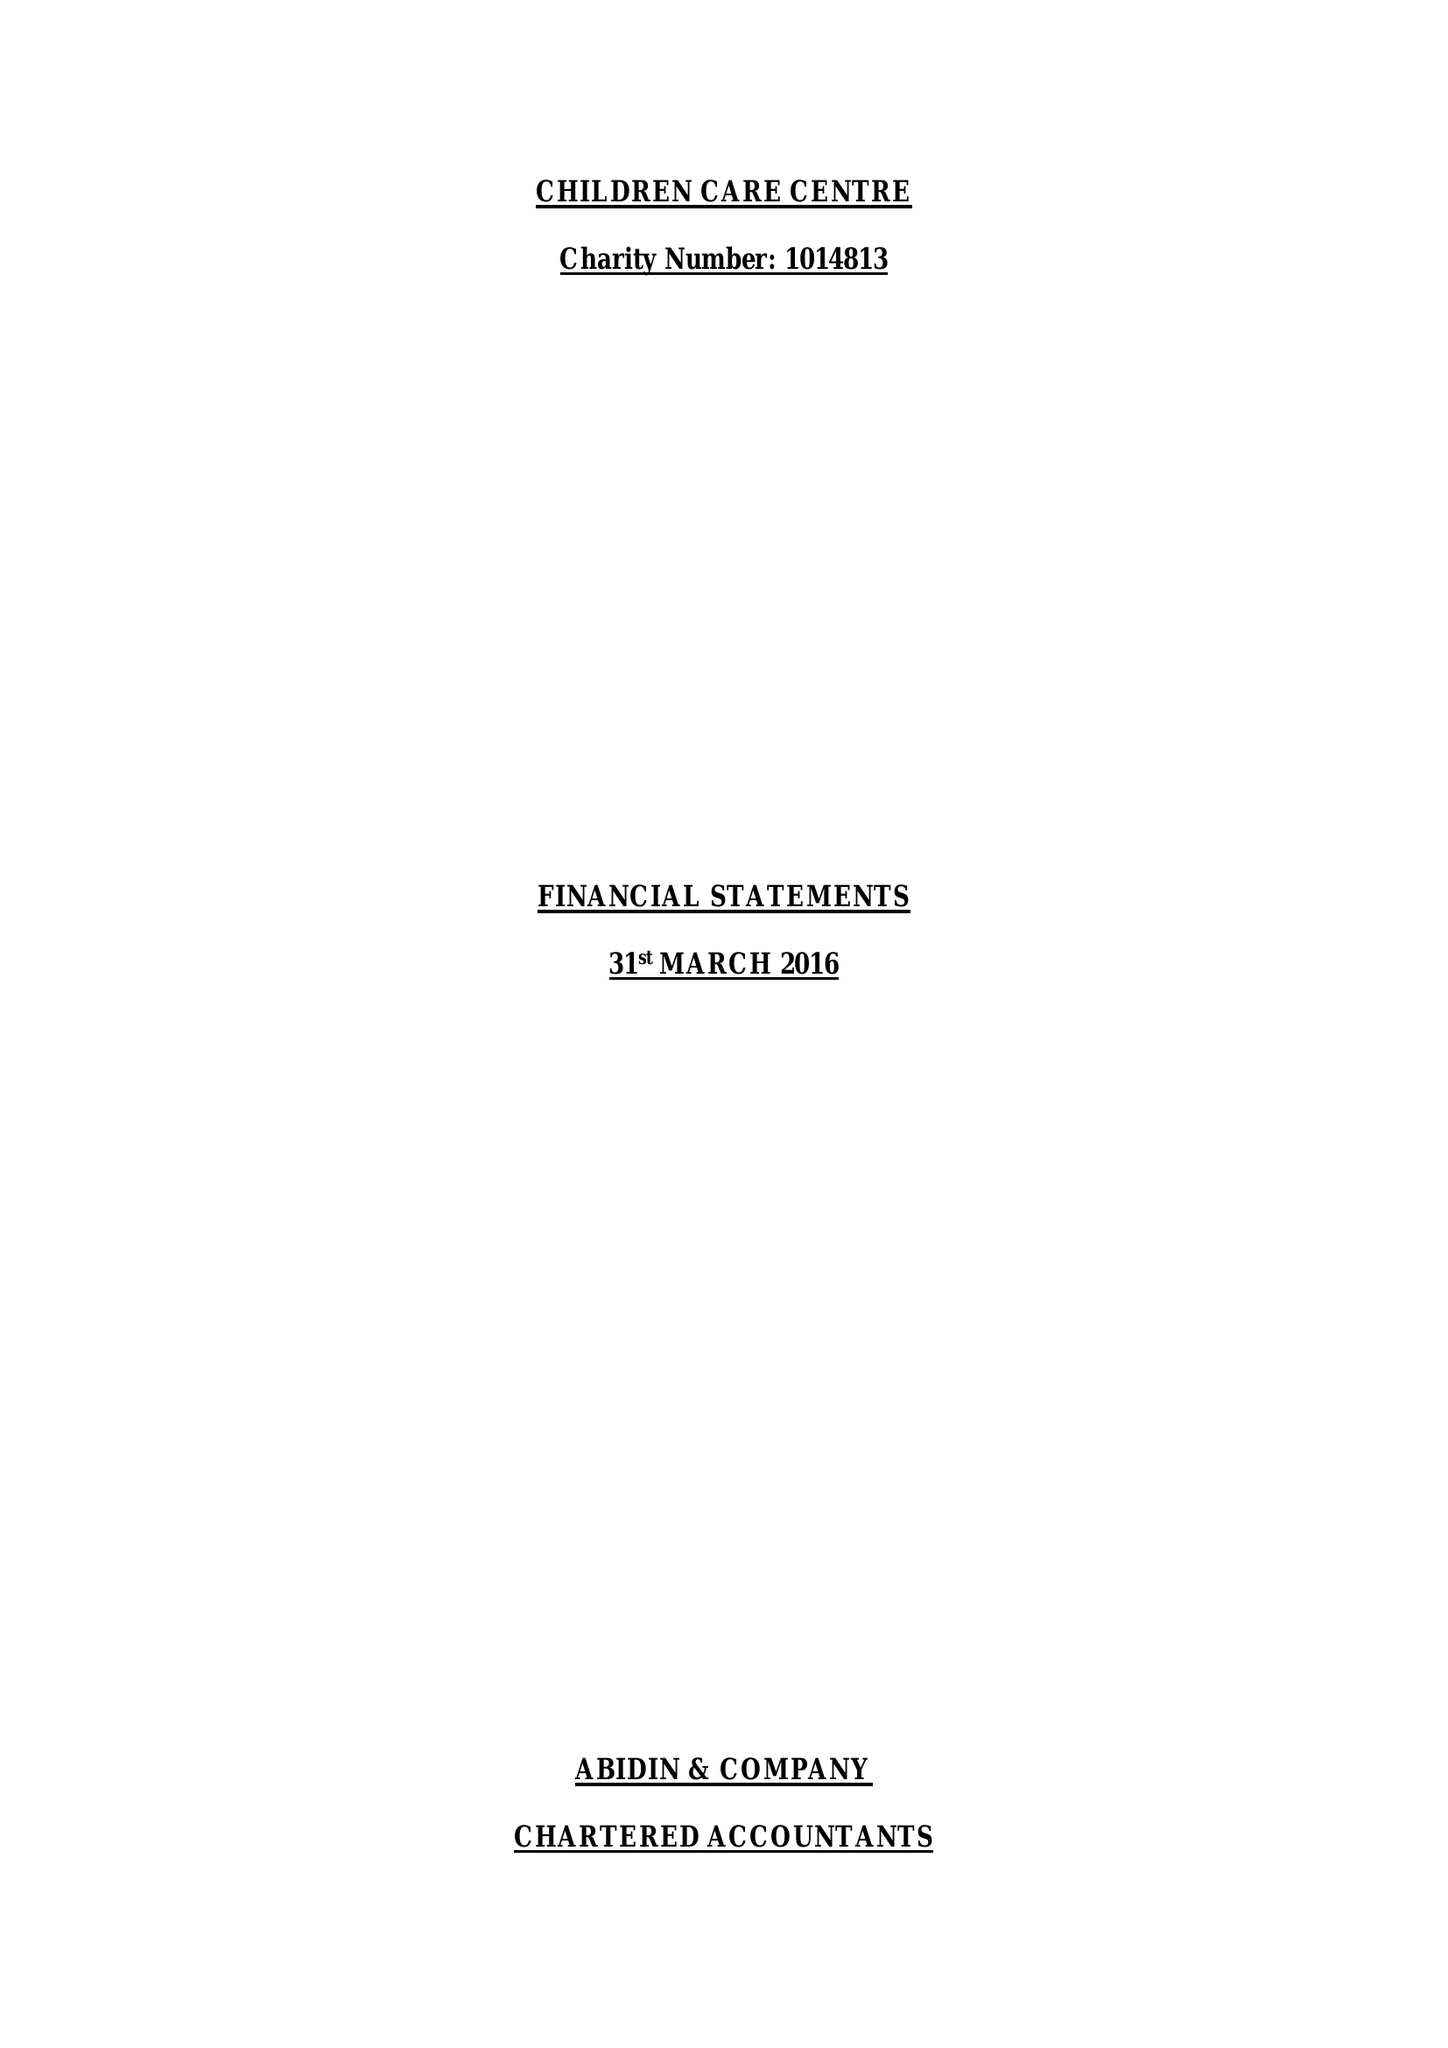What is the value for the report_date?
Answer the question using a single word or phrase. 2016-03-31 